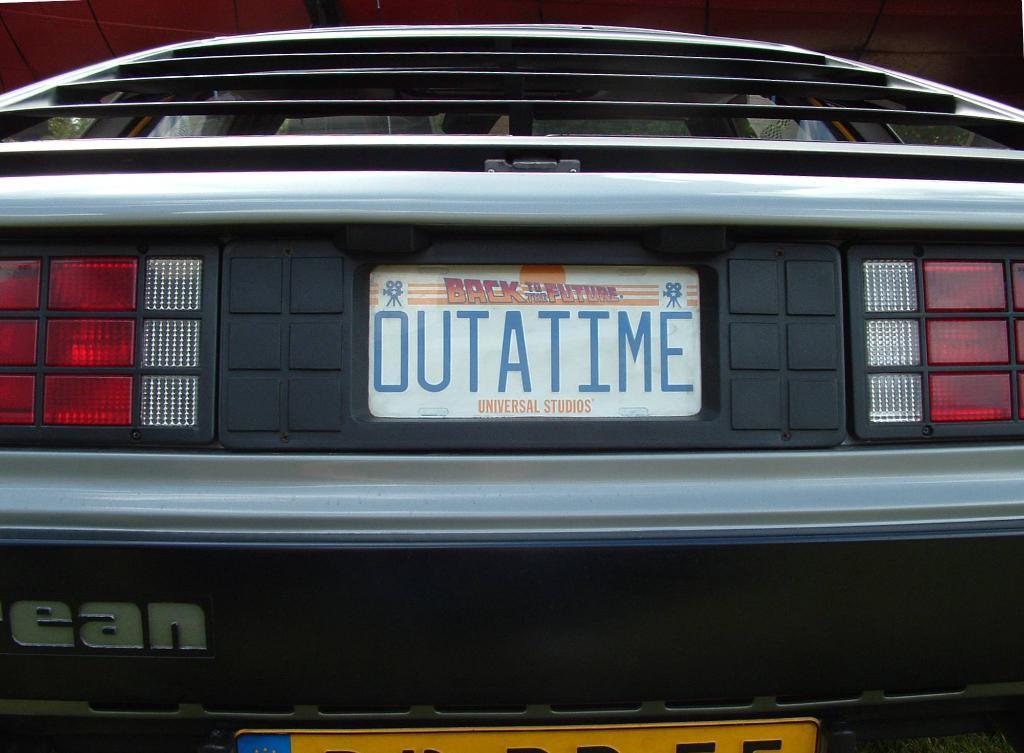How would you summarize this image in a sentence or two? In this picture we can see a vehicle which is truncated. There are lights and boards. On the whiteboard we can see text written on it. 